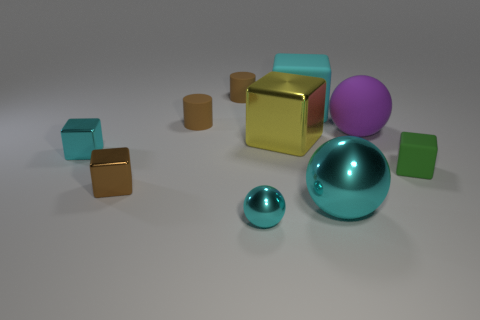What is the big yellow block made of?
Make the answer very short. Metal. What number of cyan metallic things are both in front of the tiny green cube and on the left side of the small brown shiny block?
Ensure brevity in your answer.  0. Is the size of the cyan rubber block the same as the green rubber thing?
Offer a terse response. No. There is a cyan block in front of the purple matte object; is it the same size as the cyan rubber object?
Your answer should be compact. No. The block that is right of the large matte cube is what color?
Your response must be concise. Green. How many tiny brown things are there?
Ensure brevity in your answer.  3. There is a tiny brown object that is the same material as the yellow object; what shape is it?
Provide a short and direct response. Cube. Does the small block that is behind the tiny rubber block have the same color as the rubber block in front of the purple ball?
Give a very brief answer. No. Is the number of cyan balls behind the cyan matte cube the same as the number of purple shiny spheres?
Make the answer very short. Yes. What number of cyan metal objects are behind the large metal cube?
Your response must be concise. 0. 